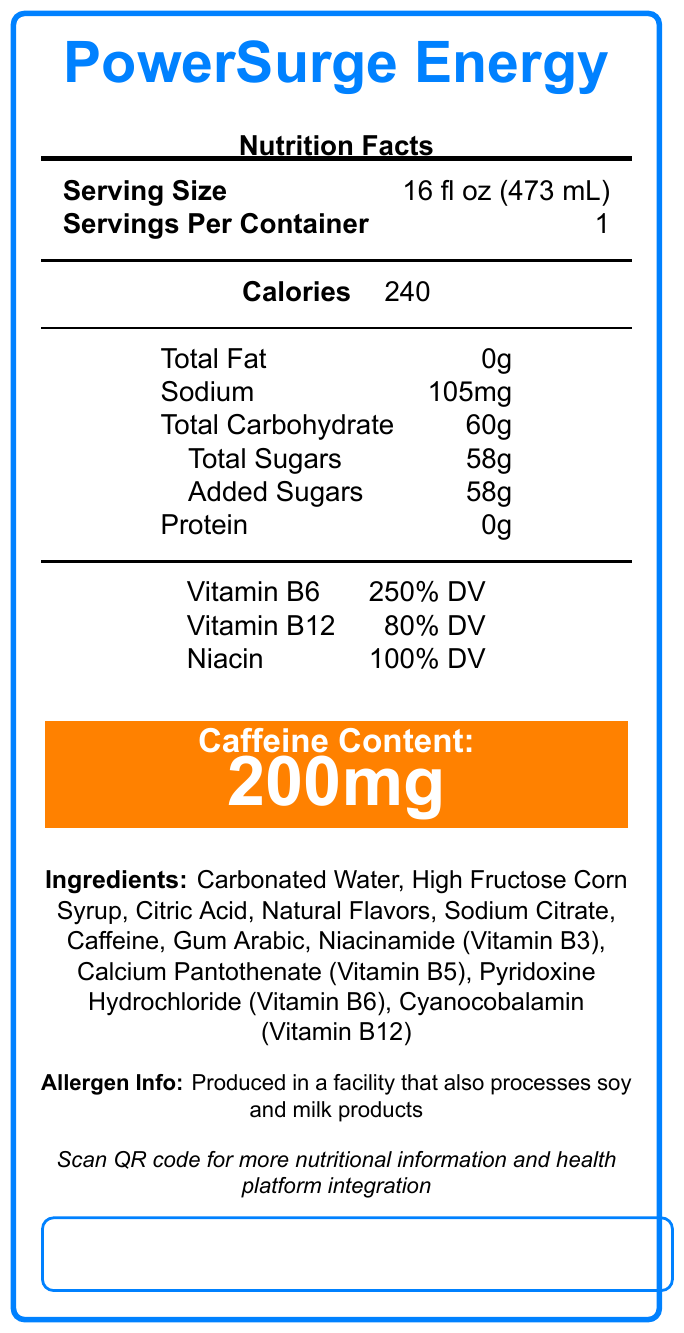What is the serving size of PowerSurge Energy? The serving size is clearly listed near the top of the document.
Answer: 16 fl oz (473 mL) How many calories are in one serving of PowerSurge Energy? The number of calories per serving is listed as 240.
Answer: 240 What is the total carbohydrate content per serving? Under the nutrition facts, it shows that Total Carbohydrate content per serving is 60g.
Answer: 60g How much caffeine is in each serving of PowerSurge Energy? The caffeine content is prominently displayed with a contrasting color in the document.
Answer: 200mg What vitamins and their daily values are included in PowerSurge Energy? These values are listed under the nutrition facts section for vitamins.
Answer: Vitamin B6: 250% DV, Vitamin B12: 80% DV, Niacin: 100% DV How many grams of added sugars are there per serving? The label shows that added sugars are 58g.
Answer: 58g Which ingredient is used as a sweetener in PowerSurge Energy? High Fructose Corn Syrup is listed as one of the ingredients.
Answer: High Fructose Corn Syrup What is the sodium content per serving? A. 55mg B. 105mg C. 155mg D. 205mg The sodium content per serving is listed as 105mg.
Answer: B. 105mg How many grams of protein are in one serving of PowerSurge Energy? The protein content per serving is 0g.
Answer: 0g Is the product produced in a facility that processes allergens? The allergen info section states that it is produced in a facility that also processes soy and milk products.
Answer: Yes What feature is used to help people understand the vitamin content in PowerSurge Energy? The UI considerations section mentions implementing hover-over tooltips for vitamin explanations.
Answer: Hover-over tooltips What kind of visual representation is used to show the macronutrient breakdown? One of the data visualization options is an interactive pie chart for the macronutrient breakdown.
Answer: Interactive pie chart Does PowerSurge Energy incorporate any accessibility features? If so, name one. The document lists multiple accessibility features, including screen reader compatible text alternatives.
Answer: Yes, screen reader compatible text alternatives Describe the main idea of the document. The document provides comprehensive details about PowerSurge Energy, including its nutritional facts, key ingredients, allergen information, and several innovative features for better user interface and accessibility.
Answer: The document describes the nutritional content and various features of PowerSurge Energy, including serving size, contents of calories, fats, vitamins, and other ingredients, as well as special UI considerations, health platform integration, and accessibility features for improved user experience. How many calories come from fat? The document provides calorie content but does not specify how many calories come from fat.
Answer: Not enough information 